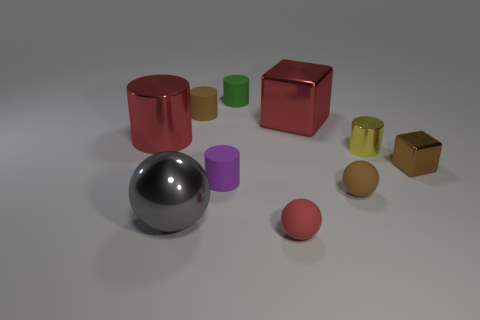What number of things are in front of the large shiny cylinder and to the right of the big gray sphere?
Offer a very short reply. 5. There is a large red object that is the same shape as the tiny green matte object; what material is it?
Your answer should be very brief. Metal. Does the large metal block have the same color as the large cylinder?
Offer a terse response. Yes. What shape is the brown object that is made of the same material as the red block?
Provide a short and direct response. Cube. There is a metallic cylinder right of the purple matte thing; does it have the same size as the brown cube?
Your response must be concise. Yes. Are there any big balls that have the same color as the big metal cylinder?
Ensure brevity in your answer.  No. There is a red metallic thing that is left of the big metal object that is right of the brown object on the left side of the small red object; what size is it?
Provide a succinct answer. Large. There is a small red thing; is its shape the same as the brown rubber object that is left of the tiny green rubber thing?
Give a very brief answer. No. How many other things are there of the same size as the yellow metal thing?
Your answer should be compact. 6. How big is the metal cylinder that is behind the small yellow cylinder?
Keep it short and to the point. Large. 